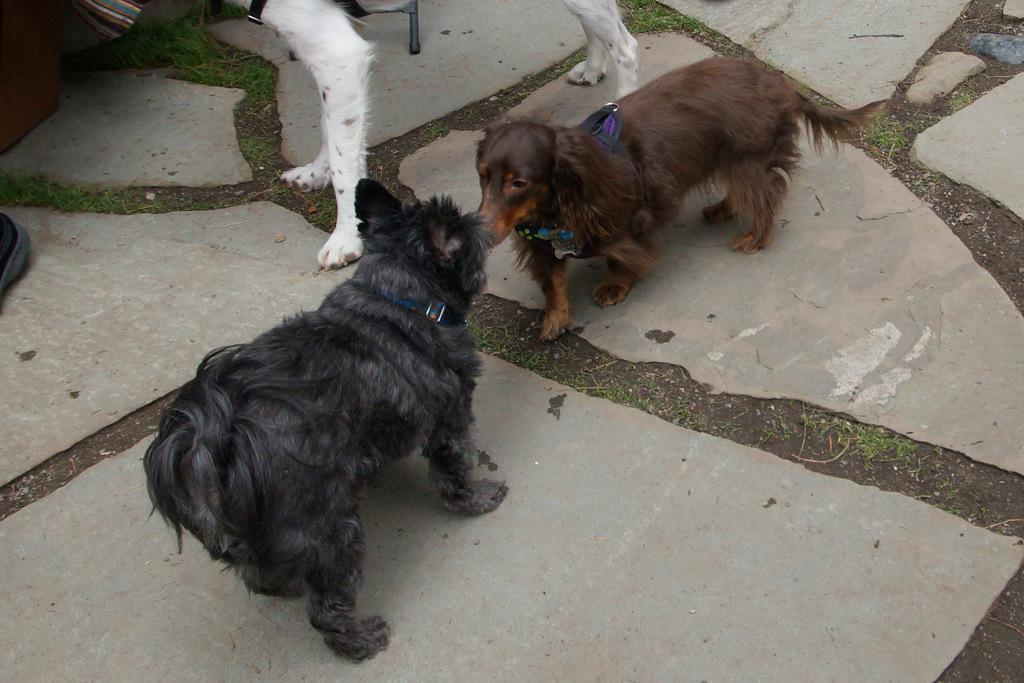What type of animals can be seen in the image? There are dogs in the image. What is the dogs' position in relation to the ground? The dogs are standing on the ground. What are the dogs wearing around their necks? The dogs are wearing neck belts. What type of vegetation is visible in the image? There is grass visible in the image. Can you describe any other objects present in the image? There are other objects present in the image, but their specific details are not mentioned in the provided facts. What type of creature is hiding behind the bead in the image? There is no bead or creature hiding behind it present in the image. 